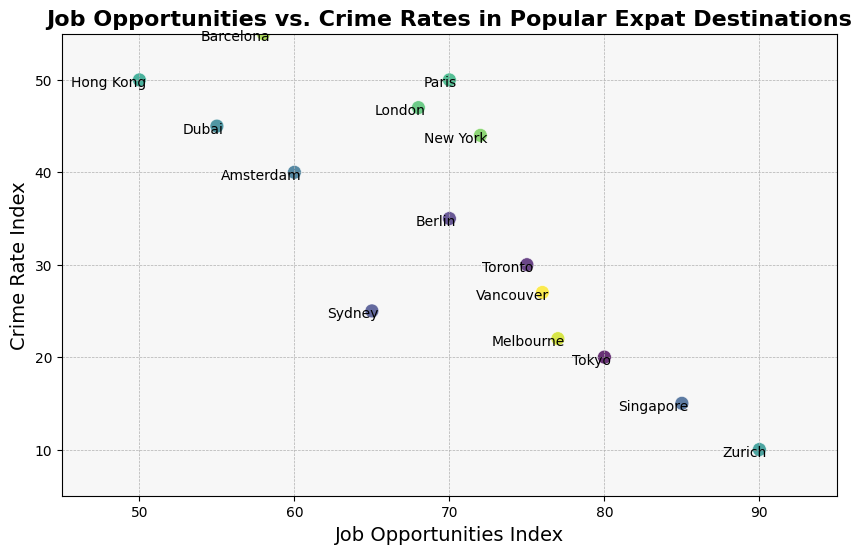Which destination has the highest Job Opportunities Index? By looking at the figure, we can identify the point that is furthest to the right along the x-axis, which represents the highest Job Opportunities Index.
Answer: Zurich Which destination has the lowest Crime Rate Index? By observing the figure, we can locate the point that is positioned lowest on the y-axis, which indicates the lowest Crime Rate Index.
Answer: Zurich What is the difference in Crime Rate Index between Hong Kong and Singapore? From the figure, find the y-values (Crime Rate Index) for Hong Kong and Singapore. Subtract the Crime Rate Index of Singapore (15) from that of Hong Kong (50).
Answer: 35 Which destinations have a Job Opportunities Index greater than 70 and a Crime Rate Index less than 30? Identify points on the figure that are to the right of the 70 mark on the x-axis (Job Opportunities Index) and below the 30 mark on the y-axis (Crime Rate Index).
Answer: Tokyo, Toronto, Melbourne, Vancouver Comparing New York and London, which has a higher Job Opportunities Index, and by how much? Check the position of both New York and London on the x-axis. New York has a Job Opportunities Index of 72 while London has 68. Subtract the Job Opportunities Index of London from that of New York (72 - 68).
Answer: New York, by 4 How many destinations have a Crime Rate Index higher than 40? Count the number of points positioned above the 40 mark on the y-axis.
Answer: 6 Which destination has the highest Job Opportunities Index and also has a Crime Rate Index below 20? Locate the rightmost point with a y-value (Crime Rate Index) below 20 on the figure.
Answer: Melbourne Which two destinations have the closest Job Opportunities Index? Look for the two points that are closest to each other along the x-axis. Tokyo (80) and Zurich (90) are very close, but Toronto (75) and Vancouver (76) are closer.
Answer: Toronto and Vancouver What is the average Job Opportunities Index for destinations with a Crime Rate Index below 30? Identify points below the 30 mark on the y-axis (Crime Rate Index). Sum the x-values of these points (Tokyo: 80, Toronto: 75, Sydney: 65, Singapore: 85, Melbourne: 77, Vancouver: 76). Divide this sum by the number of points (6). Average = (80 + 75 + 65 + 85 + 77 + 76) / 6
Answer: 76 